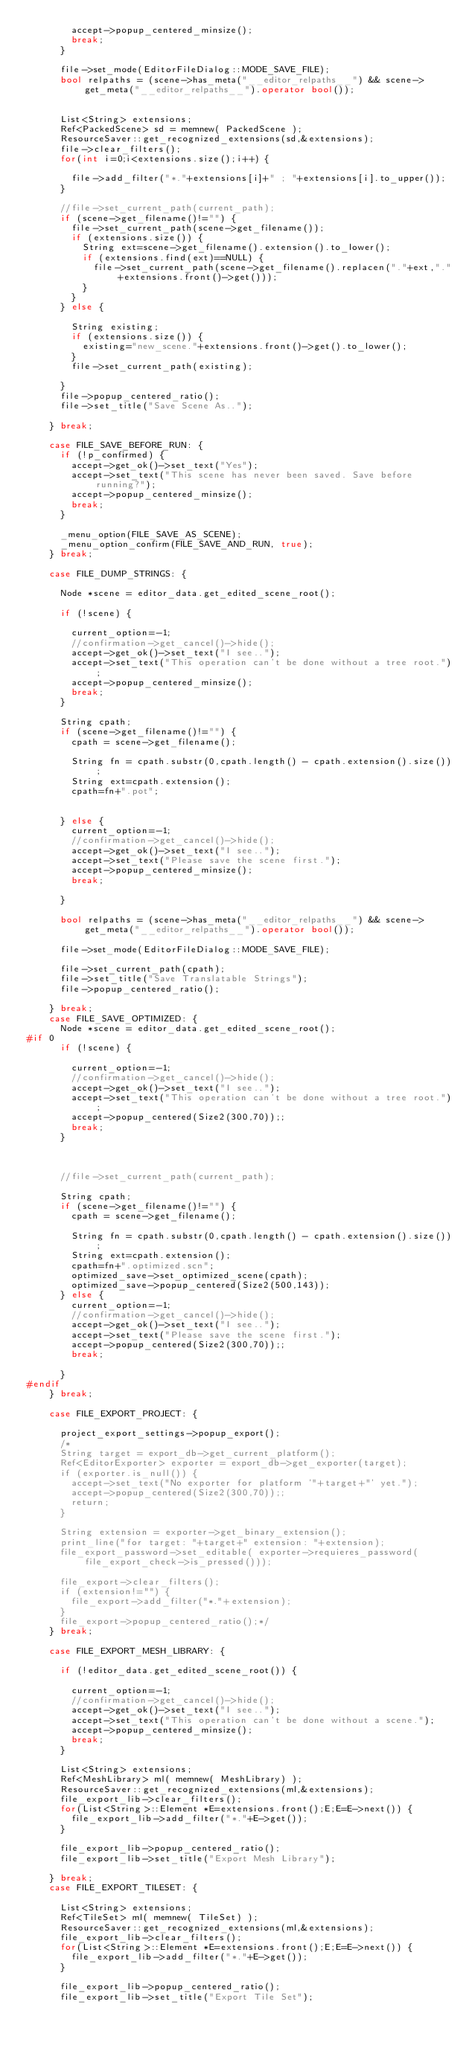<code> <loc_0><loc_0><loc_500><loc_500><_C++_>				accept->popup_centered_minsize();
				break;				
			}
			
			file->set_mode(EditorFileDialog::MODE_SAVE_FILE);
			bool relpaths = (scene->has_meta("__editor_relpaths__") && scene->get_meta("__editor_relpaths__").operator bool());


			List<String> extensions;
			Ref<PackedScene> sd = memnew( PackedScene );
			ResourceSaver::get_recognized_extensions(sd,&extensions);
			file->clear_filters();
			for(int i=0;i<extensions.size();i++) {

				file->add_filter("*."+extensions[i]+" ; "+extensions[i].to_upper());
			}
			
			//file->set_current_path(current_path);
			if (scene->get_filename()!="") {
				file->set_current_path(scene->get_filename());
				if (extensions.size()) {
					String ext=scene->get_filename().extension().to_lower();
					if (extensions.find(ext)==NULL) {
						file->set_current_path(scene->get_filename().replacen("."+ext,"."+extensions.front()->get()));
					}
				}
			} else {

				String existing;
				if (extensions.size()) {
					existing="new_scene."+extensions.front()->get().to_lower();
				}
				file->set_current_path(existing);

			}
			file->popup_centered_ratio();
			file->set_title("Save Scene As..");
			
		} break;

		case FILE_SAVE_BEFORE_RUN: {
			if (!p_confirmed) {
				accept->get_ok()->set_text("Yes");
				accept->set_text("This scene has never been saved. Save before running?");
				accept->popup_centered_minsize();
				break;
			}

			_menu_option(FILE_SAVE_AS_SCENE);
			_menu_option_confirm(FILE_SAVE_AND_RUN, true);
		} break;

		case FILE_DUMP_STRINGS: {

			Node *scene = editor_data.get_edited_scene_root();

			if (!scene) {

				current_option=-1;
				//confirmation->get_cancel()->hide();
				accept->get_ok()->set_text("I see..");
				accept->set_text("This operation can't be done without a tree root.");
				accept->popup_centered_minsize();
				break;
			}

			String cpath;
			if (scene->get_filename()!="") {
				cpath = scene->get_filename();

				String fn = cpath.substr(0,cpath.length() - cpath.extension().size());
				String ext=cpath.extension();
				cpath=fn+".pot";


			} else {
				current_option=-1;
				//confirmation->get_cancel()->hide();
				accept->get_ok()->set_text("I see..");
				accept->set_text("Please save the scene first.");
				accept->popup_centered_minsize();
				break;

			}

			bool relpaths = (scene->has_meta("__editor_relpaths__") && scene->get_meta("__editor_relpaths__").operator bool());

			file->set_mode(EditorFileDialog::MODE_SAVE_FILE);

			file->set_current_path(cpath);
			file->set_title("Save Translatable Strings");
			file->popup_centered_ratio();

		} break;
		case FILE_SAVE_OPTIMIZED: {
			Node *scene = editor_data.get_edited_scene_root();
#if 0
			if (!scene) {

				current_option=-1;
				//confirmation->get_cancel()->hide();
				accept->get_ok()->set_text("I see..");
				accept->set_text("This operation can't be done without a tree root.");
				accept->popup_centered(Size2(300,70));;
				break;
			}



			//file->set_current_path(current_path);

			String cpath;
			if (scene->get_filename()!="") {
				cpath = scene->get_filename();

				String fn = cpath.substr(0,cpath.length() - cpath.extension().size());
				String ext=cpath.extension();
				cpath=fn+".optimized.scn";
				optimized_save->set_optimized_scene(cpath);
				optimized_save->popup_centered(Size2(500,143));
			} else {
				current_option=-1;
				//confirmation->get_cancel()->hide();
				accept->get_ok()->set_text("I see..");
				accept->set_text("Please save the scene first.");
				accept->popup_centered(Size2(300,70));;
				break;

			}
#endif
		} break;

		case FILE_EXPORT_PROJECT: {

			project_export_settings->popup_export();
			/*
			String target = export_db->get_current_platform();
			Ref<EditorExporter> exporter = export_db->get_exporter(target);
			if (exporter.is_null()) {
				accept->set_text("No exporter for platform '"+target+"' yet.");
				accept->popup_centered(Size2(300,70));;
				return;
			}

			String extension = exporter->get_binary_extension();
			print_line("for target: "+target+" extension: "+extension);
			file_export_password->set_editable( exporter->requieres_password(file_export_check->is_pressed()));

			file_export->clear_filters();
			if (extension!="") {
				file_export->add_filter("*."+extension);
			}
			file_export->popup_centered_ratio();*/
		} break;

		case FILE_EXPORT_MESH_LIBRARY: {

			if (!editor_data.get_edited_scene_root()) {

				current_option=-1;
				//confirmation->get_cancel()->hide();
				accept->get_ok()->set_text("I see..");
				accept->set_text("This operation can't be done without a scene.");
				accept->popup_centered_minsize();
				break;
			}

			List<String> extensions;
			Ref<MeshLibrary> ml( memnew( MeshLibrary) );
			ResourceSaver::get_recognized_extensions(ml,&extensions);
			file_export_lib->clear_filters();
			for(List<String>::Element *E=extensions.front();E;E=E->next()) {
				file_export_lib->add_filter("*."+E->get());
			}

			file_export_lib->popup_centered_ratio();
			file_export_lib->set_title("Export Mesh Library");

		} break;
		case FILE_EXPORT_TILESET: {

			List<String> extensions;
			Ref<TileSet> ml( memnew( TileSet) );
			ResourceSaver::get_recognized_extensions(ml,&extensions);
			file_export_lib->clear_filters();
			for(List<String>::Element *E=extensions.front();E;E=E->next()) {
				file_export_lib->add_filter("*."+E->get());
			}

			file_export_lib->popup_centered_ratio();
			file_export_lib->set_title("Export Tile Set");
</code> 